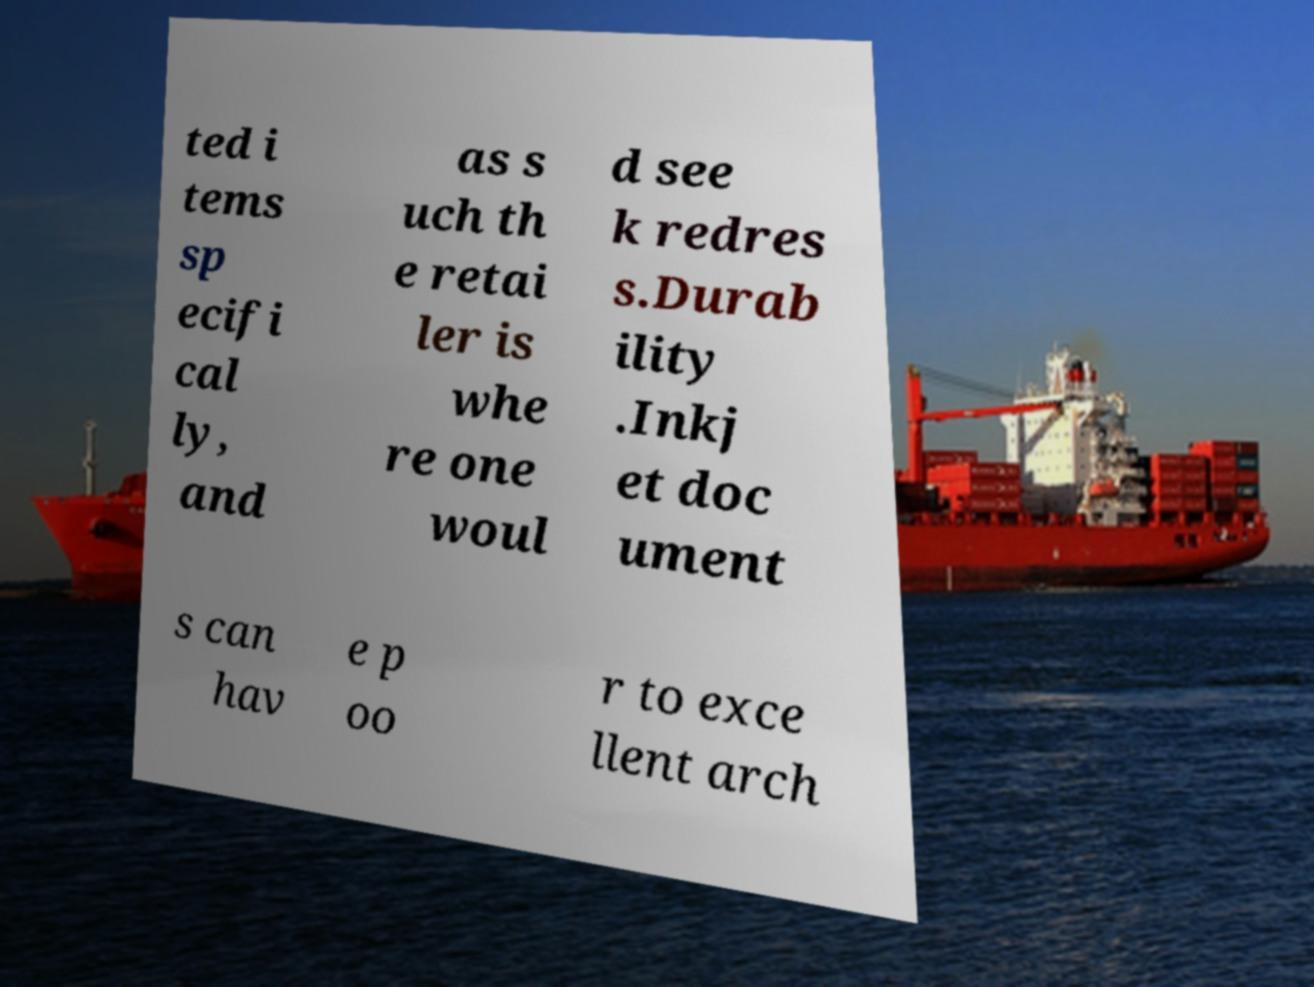There's text embedded in this image that I need extracted. Can you transcribe it verbatim? ted i tems sp ecifi cal ly, and as s uch th e retai ler is whe re one woul d see k redres s.Durab ility .Inkj et doc ument s can hav e p oo r to exce llent arch 